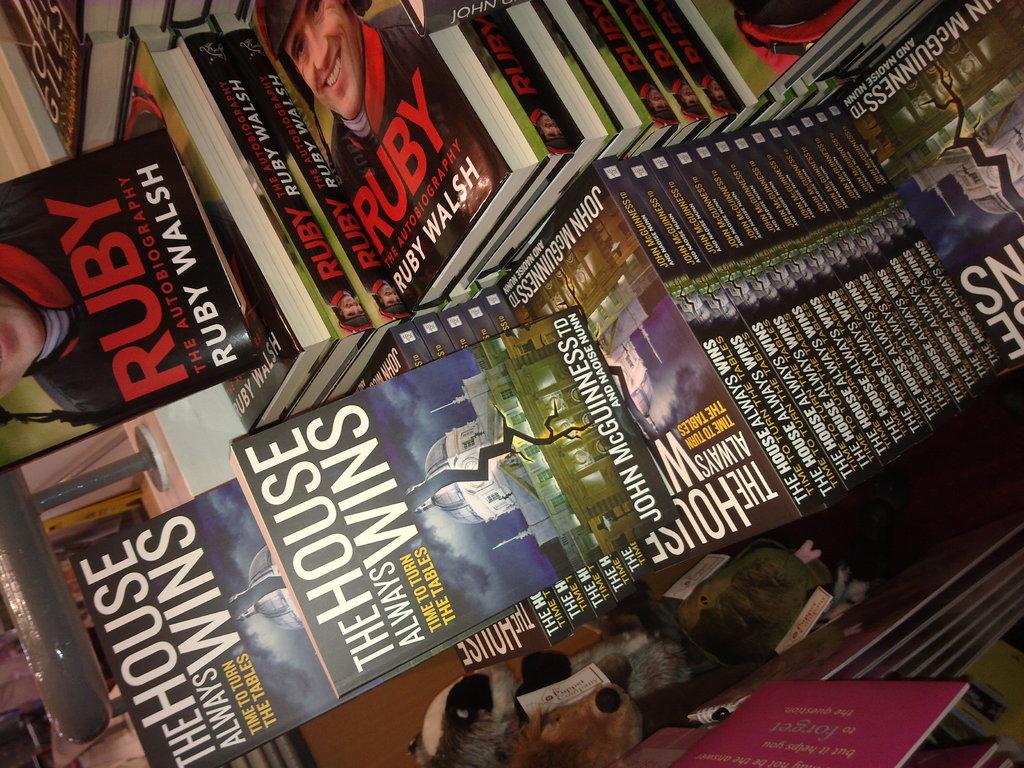Who wrote ruby?
Offer a terse response. Ruby walsh. 